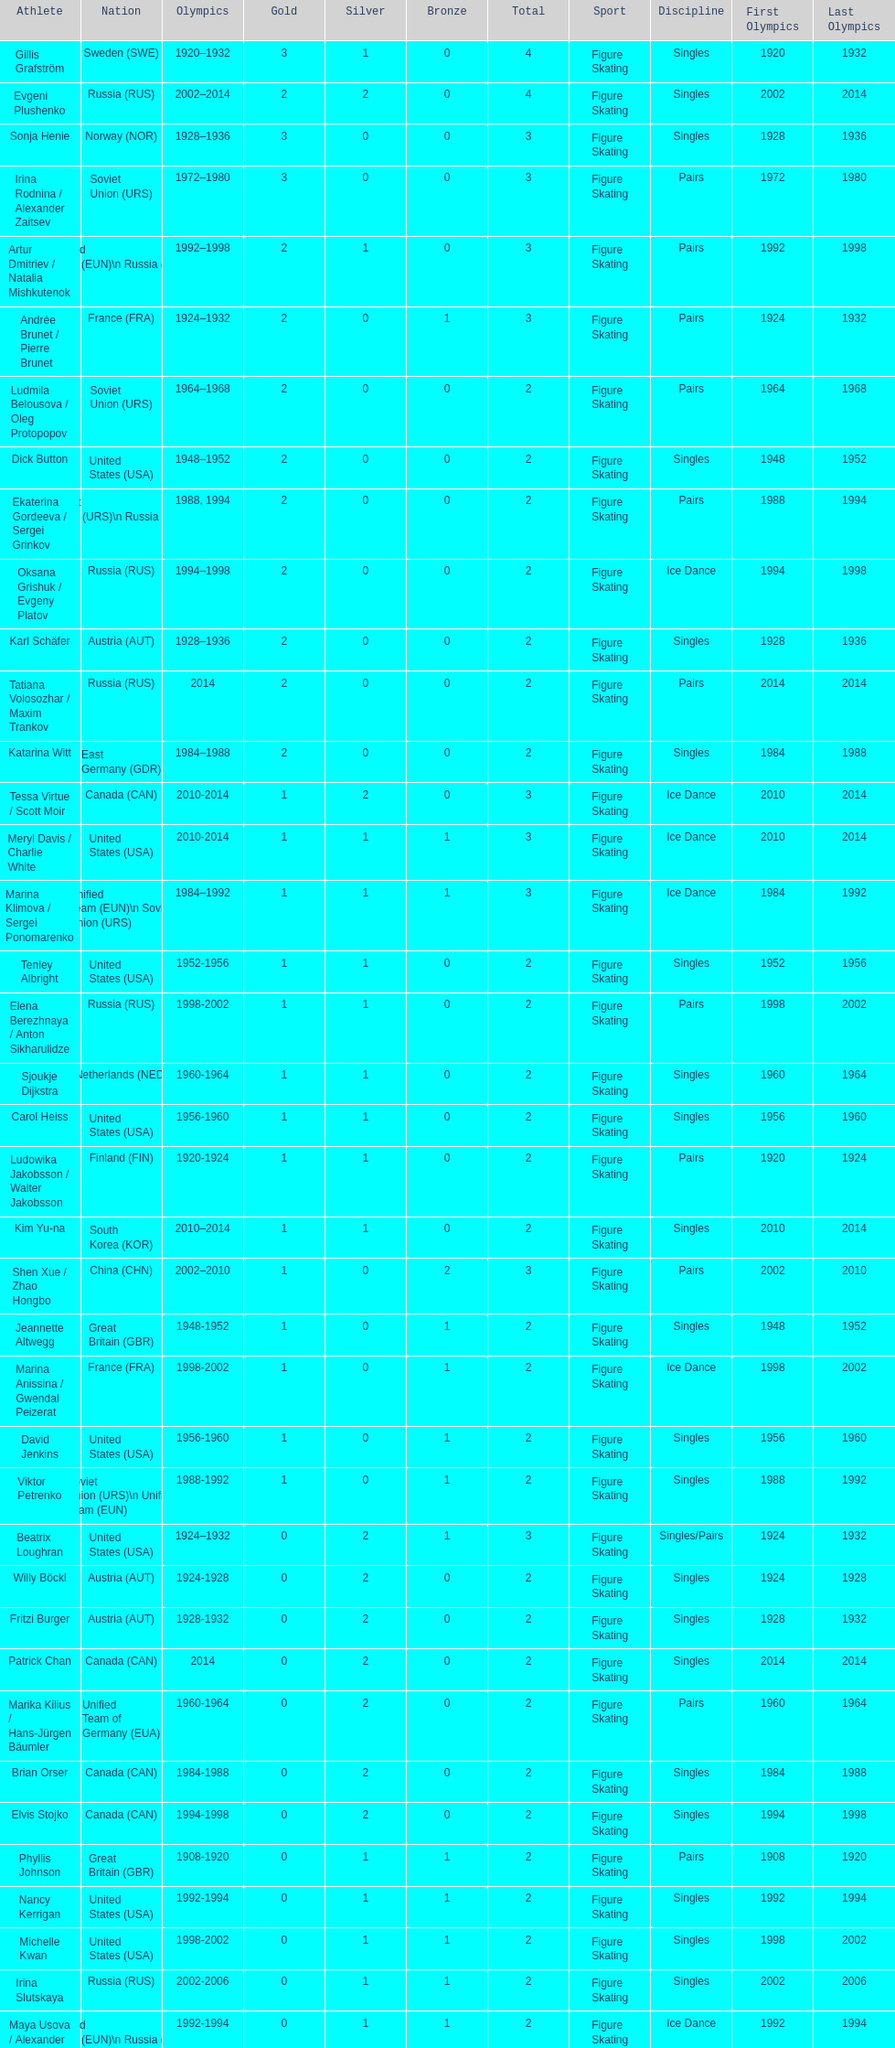How many medals have sweden and norway won combined? 7. Parse the full table. {'header': ['Athlete', 'Nation', 'Olympics', 'Gold', 'Silver', 'Bronze', 'Total', 'Sport', 'Discipline', 'First Olympics', 'Last Olympics'], 'rows': [['Gillis Grafström', 'Sweden\xa0(SWE)', '1920–1932', '3', '1', '0', '4', 'Figure Skating', 'Singles', '1920', '1932'], ['Evgeni Plushenko', 'Russia\xa0(RUS)', '2002–2014', '2', '2', '0', '4', 'Figure Skating', 'Singles', '2002', '2014'], ['Sonja Henie', 'Norway\xa0(NOR)', '1928–1936', '3', '0', '0', '3', 'Figure Skating', 'Singles', '1928', '1936'], ['Irina Rodnina / Alexander Zaitsev', 'Soviet Union\xa0(URS)', '1972–1980', '3', '0', '0', '3', 'Figure Skating', 'Pairs', '1972', '1980'], ['Artur Dmitriev / Natalia Mishkutenok', 'Unified Team\xa0(EUN)\\n\xa0Russia\xa0(RUS)', '1992–1998', '2', '1', '0', '3', 'Figure Skating', 'Pairs', '1992', '1998'], ['Andrée Brunet / Pierre Brunet', 'France\xa0(FRA)', '1924–1932', '2', '0', '1', '3', 'Figure Skating', 'Pairs', '1924', '1932'], ['Ludmila Belousova / Oleg Protopopov', 'Soviet Union\xa0(URS)', '1964–1968', '2', '0', '0', '2', 'Figure Skating', 'Pairs', '1964', '1968'], ['Dick Button', 'United States\xa0(USA)', '1948–1952', '2', '0', '0', '2', 'Figure Skating', 'Singles', '1948', '1952'], ['Ekaterina Gordeeva / Sergei Grinkov', 'Soviet Union\xa0(URS)\\n\xa0Russia\xa0(RUS)', '1988, 1994', '2', '0', '0', '2', 'Figure Skating', 'Pairs', '1988', '1994'], ['Oksana Grishuk / Evgeny Platov', 'Russia\xa0(RUS)', '1994–1998', '2', '0', '0', '2', 'Figure Skating', 'Ice Dance', '1994', '1998'], ['Karl Schäfer', 'Austria\xa0(AUT)', '1928–1936', '2', '0', '0', '2', 'Figure Skating', 'Singles', '1928', '1936'], ['Tatiana Volosozhar / Maxim Trankov', 'Russia\xa0(RUS)', '2014', '2', '0', '0', '2', 'Figure Skating', 'Pairs', '2014', '2014'], ['Katarina Witt', 'East Germany\xa0(GDR)', '1984–1988', '2', '0', '0', '2', 'Figure Skating', 'Singles', '1984', '1988'], ['Tessa Virtue / Scott Moir', 'Canada\xa0(CAN)', '2010-2014', '1', '2', '0', '3', 'Figure Skating', 'Ice Dance', '2010', '2014'], ['Meryl Davis / Charlie White', 'United States\xa0(USA)', '2010-2014', '1', '1', '1', '3', 'Figure Skating', 'Ice Dance', '2010', '2014'], ['Marina Klimova / Sergei Ponomarenko', 'Unified Team\xa0(EUN)\\n\xa0Soviet Union\xa0(URS)', '1984–1992', '1', '1', '1', '3', 'Figure Skating', 'Ice Dance', '1984', '1992'], ['Tenley Albright', 'United States\xa0(USA)', '1952-1956', '1', '1', '0', '2', 'Figure Skating', 'Singles', '1952', '1956'], ['Elena Berezhnaya / Anton Sikharulidze', 'Russia\xa0(RUS)', '1998-2002', '1', '1', '0', '2', 'Figure Skating', 'Pairs', '1998', '2002'], ['Sjoukje Dijkstra', 'Netherlands\xa0(NED)', '1960-1964', '1', '1', '0', '2', 'Figure Skating', 'Singles', '1960', '1964'], ['Carol Heiss', 'United States\xa0(USA)', '1956-1960', '1', '1', '0', '2', 'Figure Skating', 'Singles', '1956', '1960'], ['Ludowika Jakobsson / Walter Jakobsson', 'Finland\xa0(FIN)', '1920-1924', '1', '1', '0', '2', 'Figure Skating', 'Pairs', '1920', '1924'], ['Kim Yu-na', 'South Korea\xa0(KOR)', '2010–2014', '1', '1', '0', '2', 'Figure Skating', 'Singles', '2010', '2014'], ['Shen Xue / Zhao Hongbo', 'China\xa0(CHN)', '2002–2010', '1', '0', '2', '3', 'Figure Skating', 'Pairs', '2002', '2010'], ['Jeannette Altwegg', 'Great Britain\xa0(GBR)', '1948-1952', '1', '0', '1', '2', 'Figure Skating', 'Singles', '1948', '1952'], ['Marina Anissina / Gwendal Peizerat', 'France\xa0(FRA)', '1998-2002', '1', '0', '1', '2', 'Figure Skating', 'Ice Dance', '1998', '2002'], ['David Jenkins', 'United States\xa0(USA)', '1956-1960', '1', '0', '1', '2', 'Figure Skating', 'Singles', '1956', '1960'], ['Viktor Petrenko', 'Soviet Union\xa0(URS)\\n\xa0Unified Team\xa0(EUN)', '1988-1992', '1', '0', '1', '2', 'Figure Skating', 'Singles', '1988', '1992'], ['Beatrix Loughran', 'United States\xa0(USA)', '1924–1932', '0', '2', '1', '3', 'Figure Skating', 'Singles/Pairs', '1924', '1932'], ['Willy Böckl', 'Austria\xa0(AUT)', '1924-1928', '0', '2', '0', '2', 'Figure Skating', 'Singles', '1924', '1928'], ['Fritzi Burger', 'Austria\xa0(AUT)', '1928-1932', '0', '2', '0', '2', 'Figure Skating', 'Singles', '1928', '1932'], ['Patrick Chan', 'Canada\xa0(CAN)', '2014', '0', '2', '0', '2', 'Figure Skating', 'Singles', '2014', '2014'], ['Marika Kilius / Hans-Jürgen Bäumler', 'Unified Team of Germany\xa0(EUA)', '1960-1964', '0', '2', '0', '2', 'Figure Skating', 'Pairs', '1960', '1964'], ['Brian Orser', 'Canada\xa0(CAN)', '1984-1988', '0', '2', '0', '2', 'Figure Skating', 'Singles', '1984', '1988'], ['Elvis Stojko', 'Canada\xa0(CAN)', '1994-1998', '0', '2', '0', '2', 'Figure Skating', 'Singles', '1994', '1998'], ['Phyllis Johnson', 'Great Britain\xa0(GBR)', '1908-1920', '0', '1', '1', '2', 'Figure Skating', 'Pairs', '1908', '1920'], ['Nancy Kerrigan', 'United States\xa0(USA)', '1992-1994', '0', '1', '1', '2', 'Figure Skating', 'Singles', '1992', '1994'], ['Michelle Kwan', 'United States\xa0(USA)', '1998-2002', '0', '1', '1', '2', 'Figure Skating', 'Singles', '1998', '2002'], ['Irina Slutskaya', 'Russia\xa0(RUS)', '2002-2006', '0', '1', '1', '2', 'Figure Skating', 'Singles', '2002', '2006'], ['Maya Usova / Alexander Zhulin', 'Unified Team\xa0(EUN)\\n\xa0Russia\xa0(RUS)', '1992-1994', '0', '1', '1', '2', 'Figure Skating', 'Ice Dance', '1992', '1994'], ['Isabelle Brasseur / Lloyd Eisler', 'Canada\xa0(CAN)', '1992-1994', '0', '0', '2', '2', 'Figure Skating', 'Pairs', '1992', '1994'], ['Philippe Candeloro', 'France\xa0(FRA)', '1994-1998', '0', '0', '2', '2', 'Figure Skating', 'Singles', '1994', '1998'], ['Manuela Groß / Uwe Kagelmann', 'East Germany\xa0(GDR)', '1972-1976', '0', '0', '2', '2', 'Figure Skating', 'Pairs', '1972', '1976'], ['Chen Lu', 'China\xa0(CHN)', '1994-1998', '0', '0', '2', '2', 'Figure Skating', 'Singles', '1994', '1998'], ['Marianna Nagy / László Nagy', 'Hungary\xa0(HUN)', '1952-1956', '0', '0', '2', '2', 'Figure Skating', 'Pairs', '1952', '1956'], ['Patrick Péra', 'France\xa0(FRA)', '1968-1972', '0', '0', '2', '2', 'Figure Skating', 'Singles', '1968', '1972'], ['Emília Rotter / László Szollás', 'Hungary\xa0(HUN)', '1932-1936', '0', '0', '2', '2', 'Figure Skating', 'Pairs', '1932', '1936'], ['Aliona Savchenko / Robin Szolkowy', 'Germany\xa0(GER)', '2010-2014', '0', '0', '2', '2', 'Figure Skating', 'Pairs', '2010', '2014']]} 